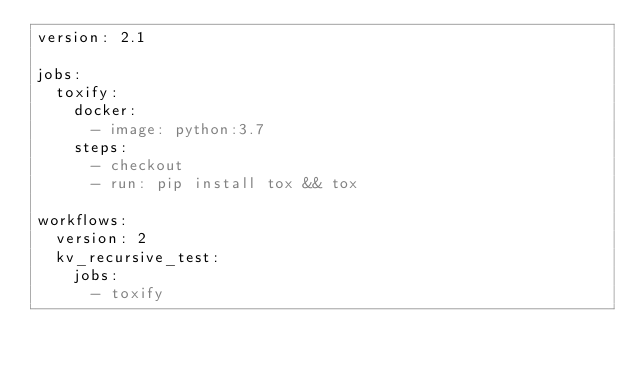Convert code to text. <code><loc_0><loc_0><loc_500><loc_500><_YAML_>version: 2.1

jobs:
  toxify:
    docker:
      - image: python:3.7
    steps:
      - checkout
      - run: pip install tox && tox

workflows:
  version: 2
  kv_recursive_test:
    jobs:
      - toxify
</code> 